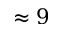<formula> <loc_0><loc_0><loc_500><loc_500>\approx 9</formula> 